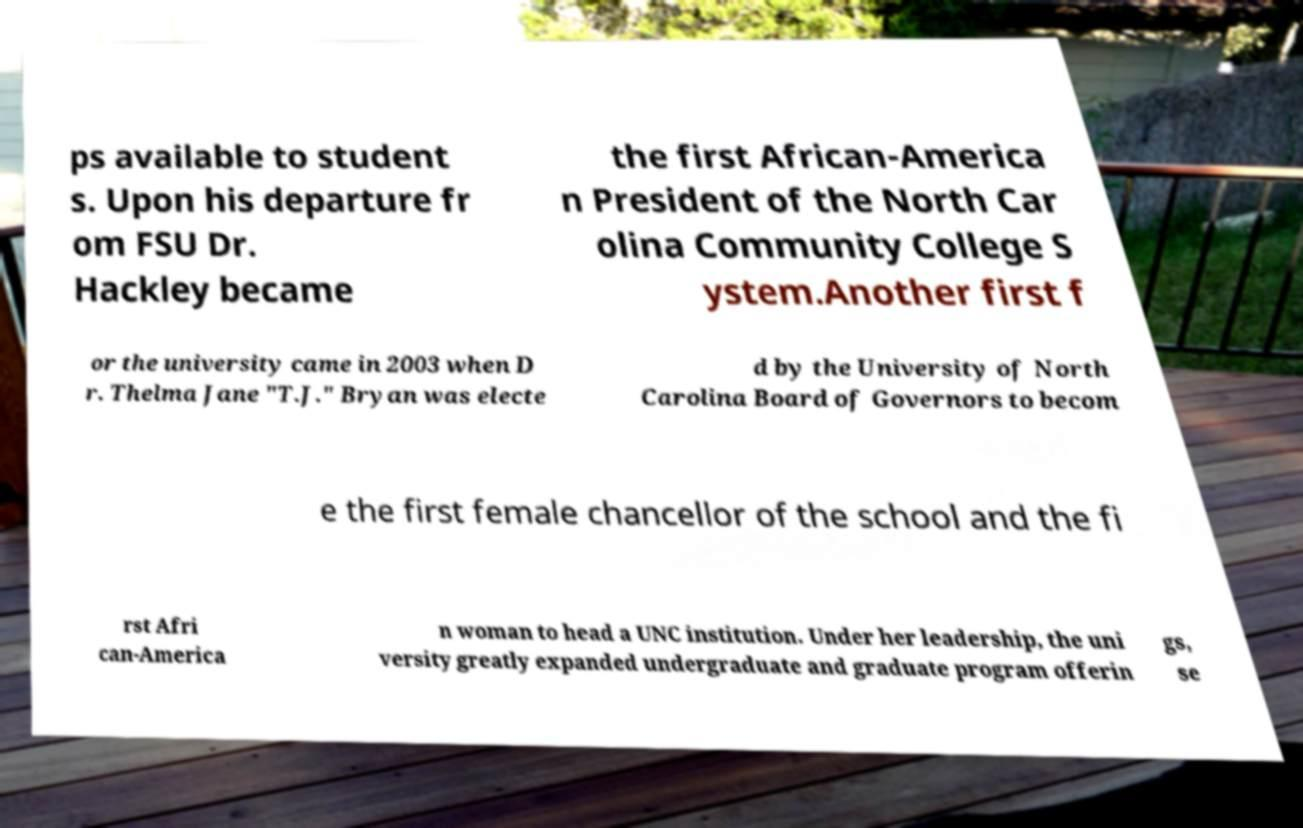Please identify and transcribe the text found in this image. ps available to student s. Upon his departure fr om FSU Dr. Hackley became the first African-America n President of the North Car olina Community College S ystem.Another first f or the university came in 2003 when D r. Thelma Jane "T.J." Bryan was electe d by the University of North Carolina Board of Governors to becom e the first female chancellor of the school and the fi rst Afri can-America n woman to head a UNC institution. Under her leadership, the uni versity greatly expanded undergraduate and graduate program offerin gs, se 